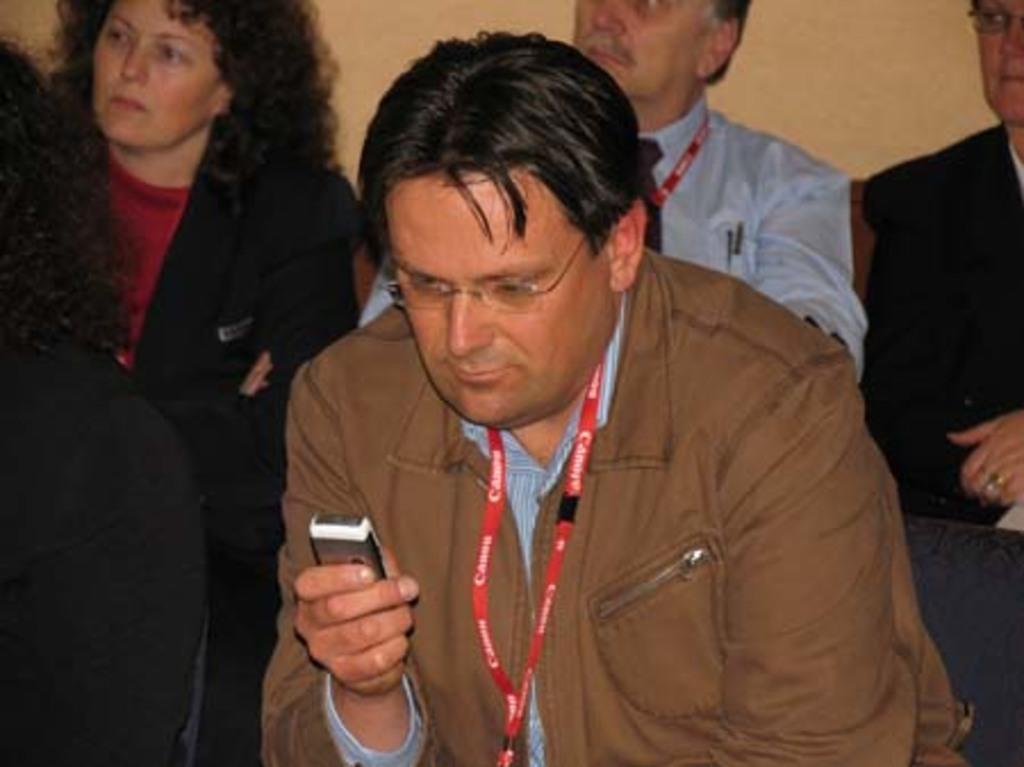How would you summarize this image in a sentence or two? In the foreground of the picture there is a person holding mobile. On the left there is a person sitting in chair. In the background there are people sitting. 